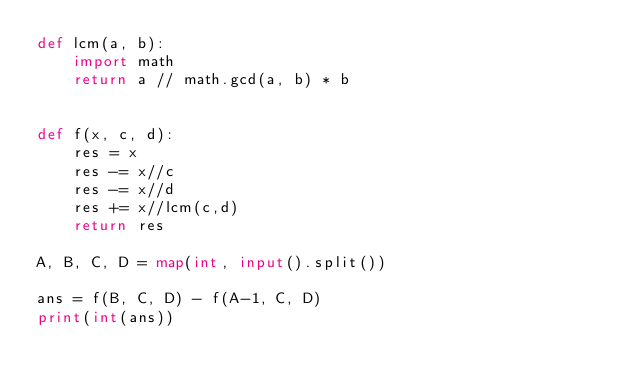<code> <loc_0><loc_0><loc_500><loc_500><_Python_>def lcm(a, b):
    import math
    return a // math.gcd(a, b) * b


def f(x, c, d):
    res = x
    res -= x//c
    res -= x//d
    res += x//lcm(c,d)
    return res

A, B, C, D = map(int, input().split())

ans = f(B, C, D) - f(A-1, C, D)
print(int(ans))</code> 